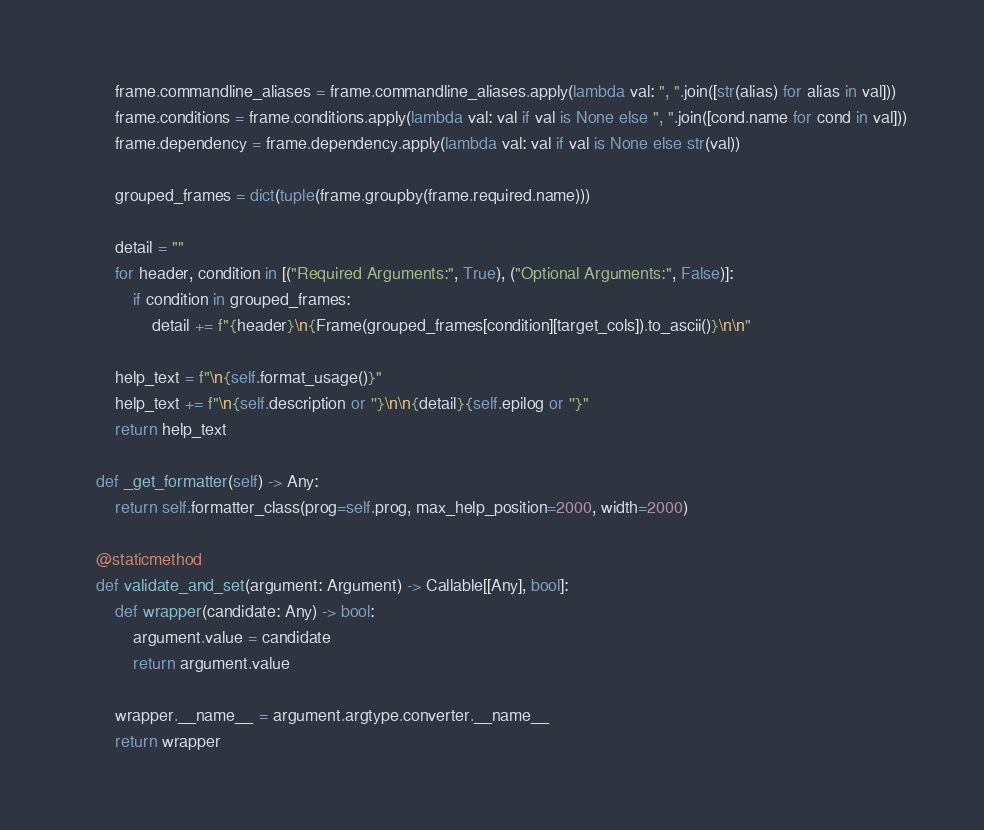Convert code to text. <code><loc_0><loc_0><loc_500><loc_500><_Python_>        frame.commandline_aliases = frame.commandline_aliases.apply(lambda val: ", ".join([str(alias) for alias in val]))
        frame.conditions = frame.conditions.apply(lambda val: val if val is None else ", ".join([cond.name for cond in val]))
        frame.dependency = frame.dependency.apply(lambda val: val if val is None else str(val))

        grouped_frames = dict(tuple(frame.groupby(frame.required.name)))

        detail = ""
        for header, condition in [("Required Arguments:", True), ("Optional Arguments:", False)]:
            if condition in grouped_frames:
                detail += f"{header}\n{Frame(grouped_frames[condition][target_cols]).to_ascii()}\n\n"

        help_text = f"\n{self.format_usage()}"
        help_text += f"\n{self.description or ''}\n\n{detail}{self.epilog or ''}"
        return help_text

    def _get_formatter(self) -> Any:
        return self.formatter_class(prog=self.prog, max_help_position=2000, width=2000)

    @staticmethod
    def validate_and_set(argument: Argument) -> Callable[[Any], bool]:
        def wrapper(candidate: Any) -> bool:
            argument.value = candidate
            return argument.value

        wrapper.__name__ = argument.argtype.converter.__name__
        return wrapper
</code> 